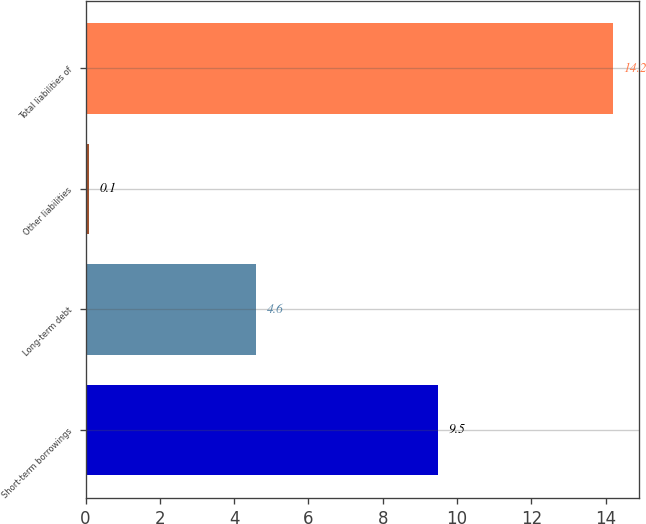Convert chart to OTSL. <chart><loc_0><loc_0><loc_500><loc_500><bar_chart><fcel>Short-term borrowings<fcel>Long-term debt<fcel>Other liabilities<fcel>Total liabilities of<nl><fcel>9.5<fcel>4.6<fcel>0.1<fcel>14.2<nl></chart> 